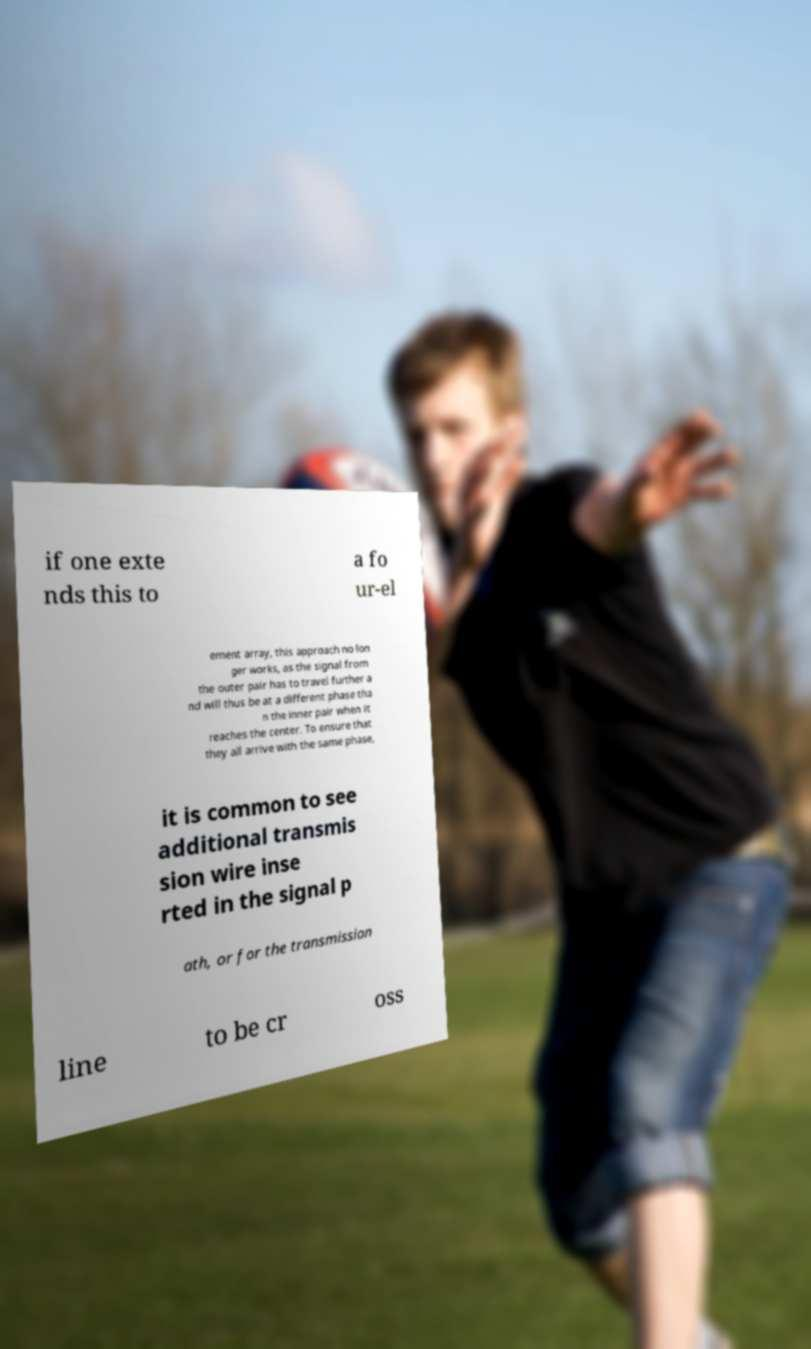Please identify and transcribe the text found in this image. if one exte nds this to a fo ur-el ement array, this approach no lon ger works, as the signal from the outer pair has to travel further a nd will thus be at a different phase tha n the inner pair when it reaches the center. To ensure that they all arrive with the same phase, it is common to see additional transmis sion wire inse rted in the signal p ath, or for the transmission line to be cr oss 